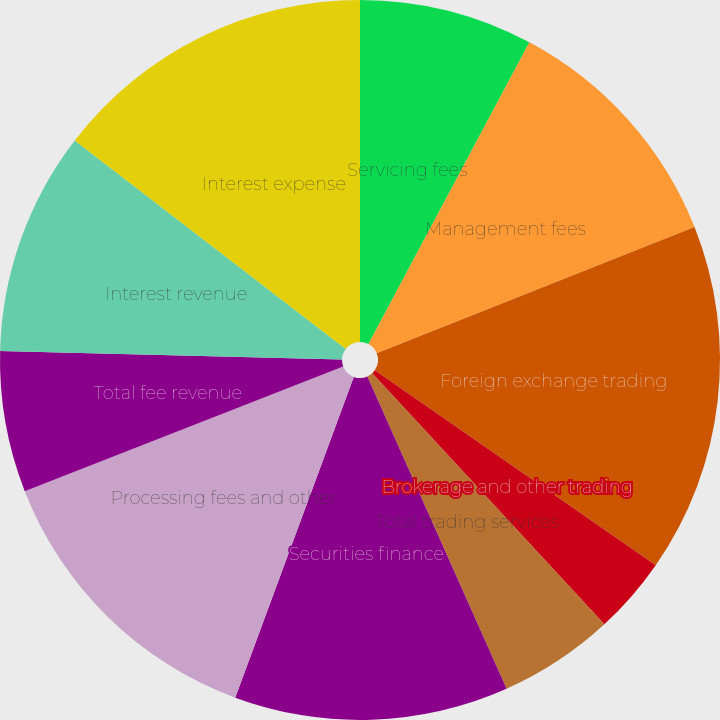<chart> <loc_0><loc_0><loc_500><loc_500><pie_chart><fcel>Servicing fees<fcel>Management fees<fcel>Foreign exchange trading<fcel>Brokerage and other trading<fcel>Total trading services<fcel>Securities finance<fcel>Processing fees and other<fcel>Total fee revenue<fcel>Interest revenue<fcel>Interest expense<nl><fcel>7.8%<fcel>11.18%<fcel>15.68%<fcel>3.47%<fcel>5.2%<fcel>12.31%<fcel>13.43%<fcel>6.33%<fcel>10.05%<fcel>14.56%<nl></chart> 